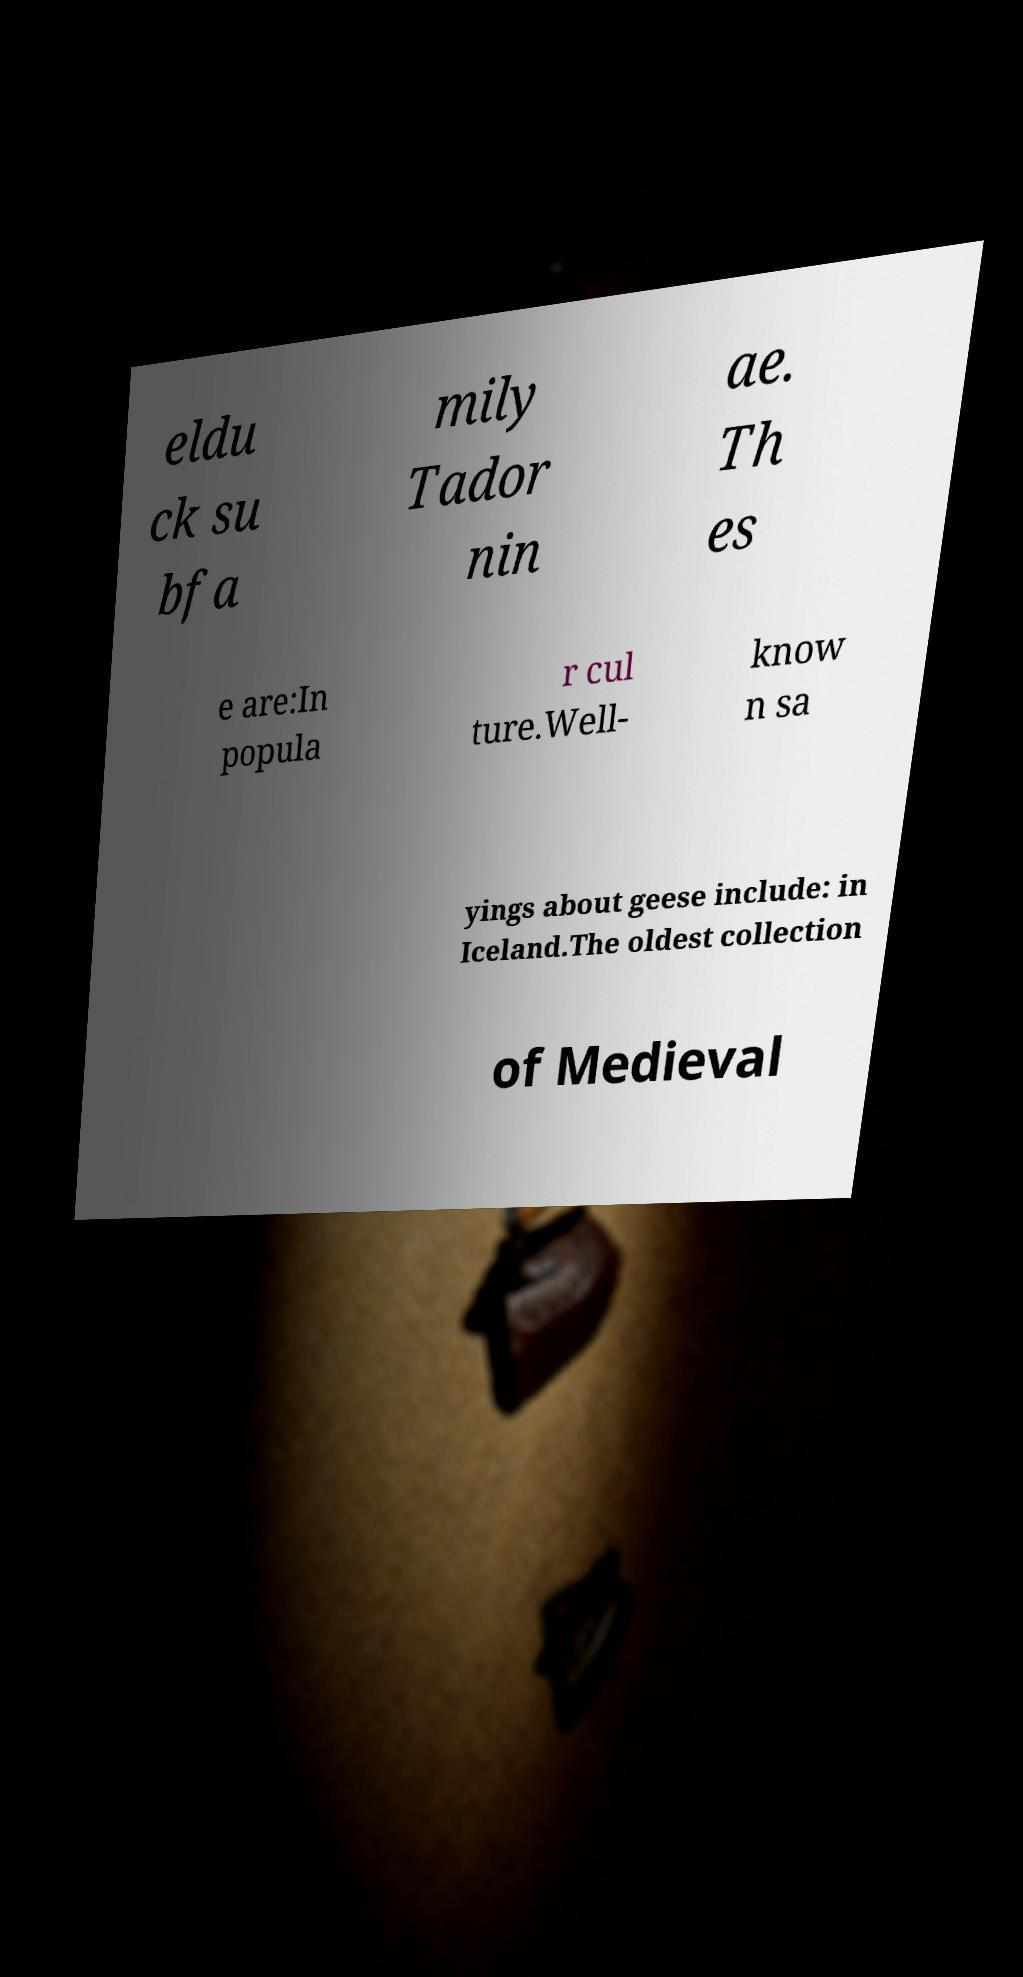For documentation purposes, I need the text within this image transcribed. Could you provide that? eldu ck su bfa mily Tador nin ae. Th es e are:In popula r cul ture.Well- know n sa yings about geese include: in Iceland.The oldest collection of Medieval 